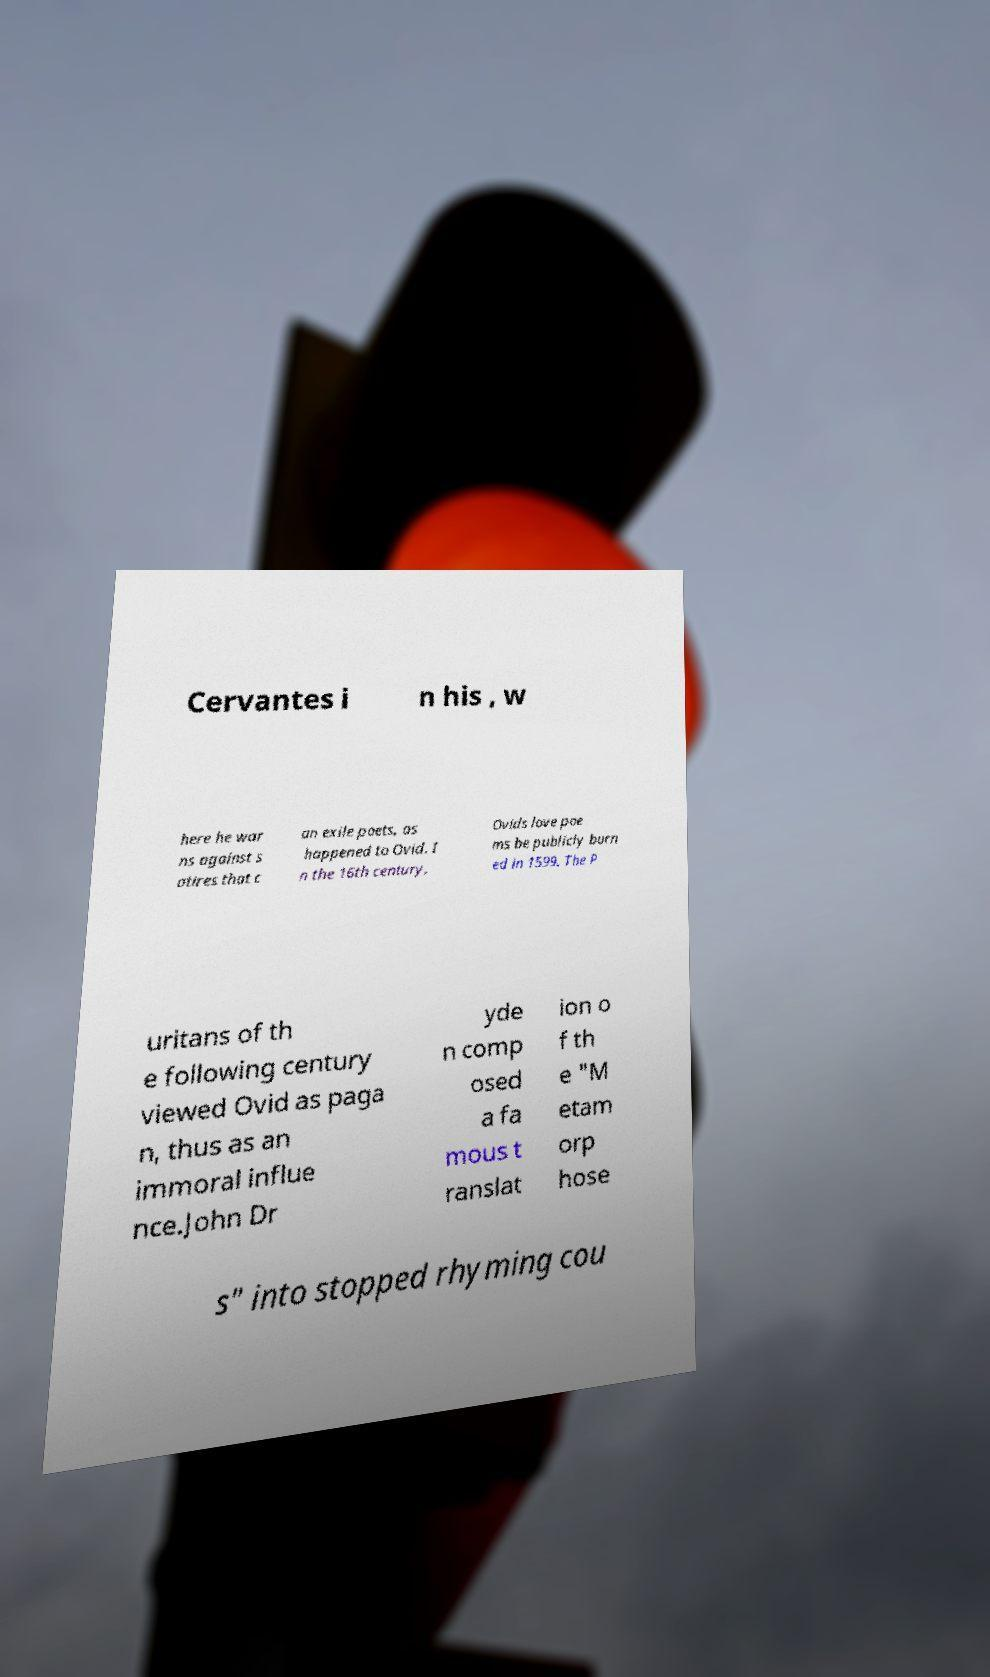Could you assist in decoding the text presented in this image and type it out clearly? Cervantes i n his , w here he war ns against s atires that c an exile poets, as happened to Ovid. I n the 16th century, Ovids love poe ms be publicly burn ed in 1599. The P uritans of th e following century viewed Ovid as paga n, thus as an immoral influe nce.John Dr yde n comp osed a fa mous t ranslat ion o f th e "M etam orp hose s" into stopped rhyming cou 